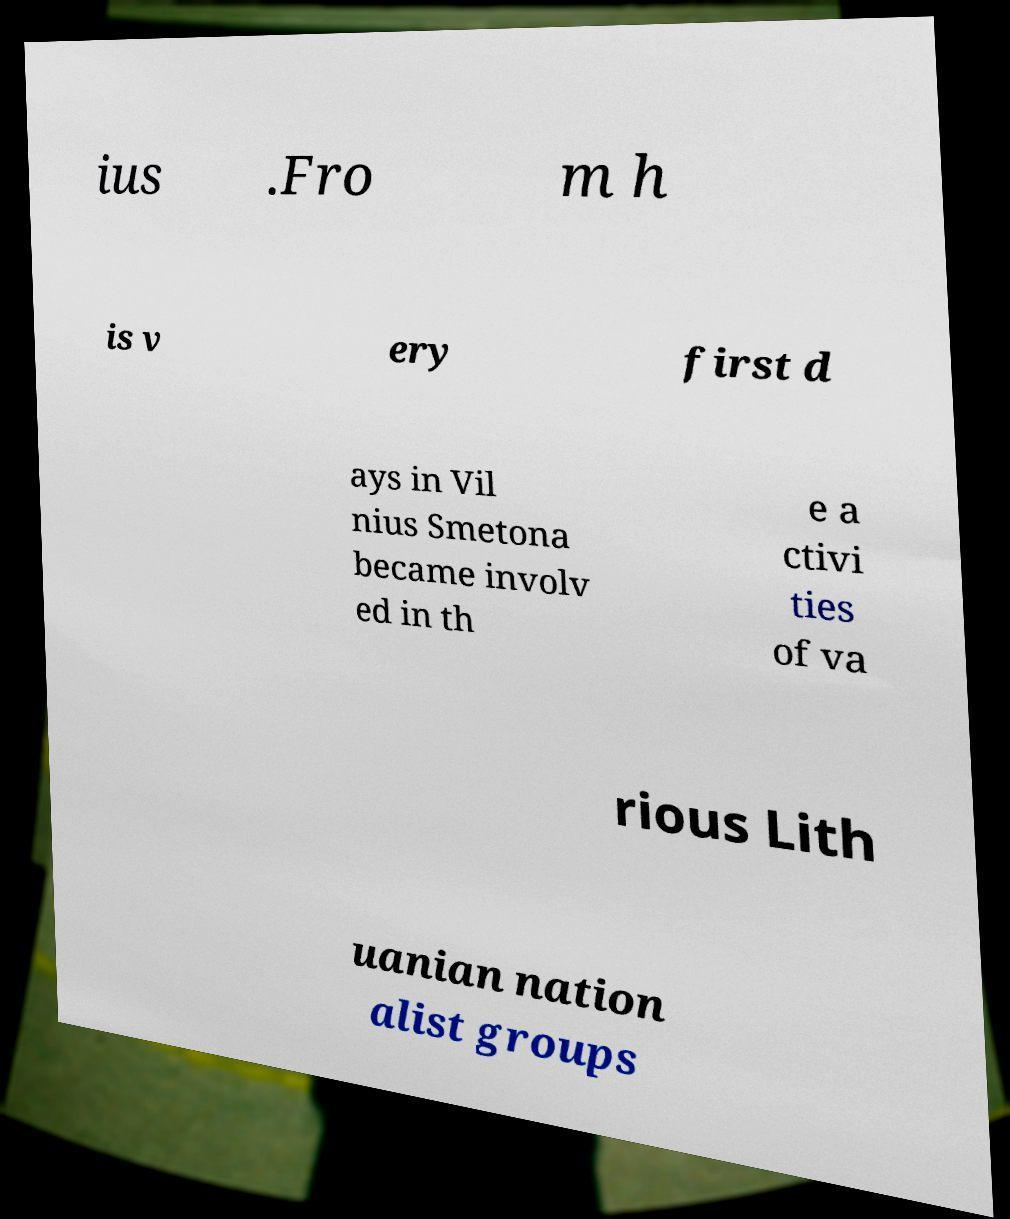Could you extract and type out the text from this image? ius .Fro m h is v ery first d ays in Vil nius Smetona became involv ed in th e a ctivi ties of va rious Lith uanian nation alist groups 